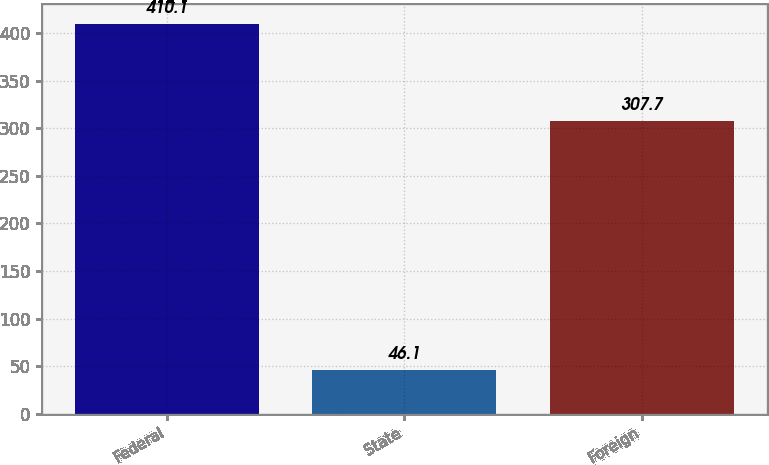Convert chart to OTSL. <chart><loc_0><loc_0><loc_500><loc_500><bar_chart><fcel>Federal<fcel>State<fcel>Foreign<nl><fcel>410.1<fcel>46.1<fcel>307.7<nl></chart> 